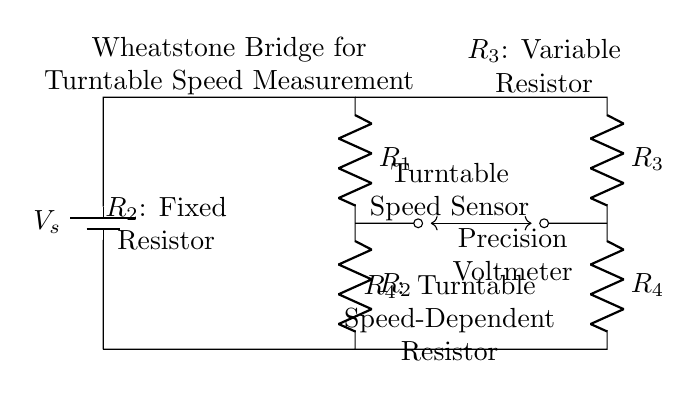What is the type of the circuit? The circuit is a Wheatstone Bridge, which is specifically designed for precise measurements of resistance and is commonly used in applications such as turntable speed measurement.
Answer: Wheatstone Bridge What does R2 represent? R2 is labeled as a fixed resistor, which provides a stable reference point in the bridge circuit to compare other resistances against.
Answer: Fixed Resistor What is the role of the Turntable Speed Sensor? The Turntable Speed Sensor takes input from the turntable to assess and adjust the speed, providing feedback to the circuit to ensure accurate measurements.
Answer: Turntable Speed Sensor How many resistors are present in this circuit? Counting R1, R2, R3, and R4, there are a total of four resistors involved in the Wheatstone Bridge circuit configuration.
Answer: Four Which resistor is variable? R3 is indicated as a variable resistor, allowing it to be adjusted to fine-tune the balance of the bridge circuit for precise measurements.
Answer: Variable Resistor What measurement device is included in this circuit? The Precision Voltmeter is present in the circuit, which measures the voltage difference across the bridge to determine if it is balanced or unbalanced, indicating the resistance values.
Answer: Precision Voltmeter What condition is indicated by the voltmeter reading? The voltmeter reading indicates whether the Wheatstone Bridge is balanced or not; zero voltage implies a balanced circuit, and any other reading indicates an imbalance that requires adjustment.
Answer: Balanced or Unbalanced 